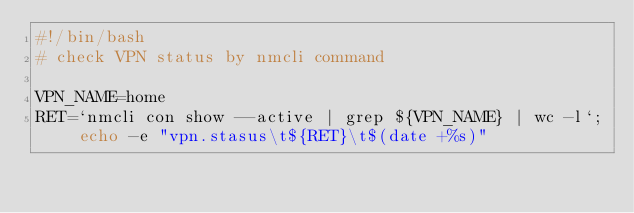Convert code to text. <code><loc_0><loc_0><loc_500><loc_500><_Bash_>#!/bin/bash
# check VPN status by nmcli command

VPN_NAME=home
RET=`nmcli con show --active | grep ${VPN_NAME} | wc -l`; echo -e "vpn.stasus\t${RET}\t$(date +%s)"
</code> 